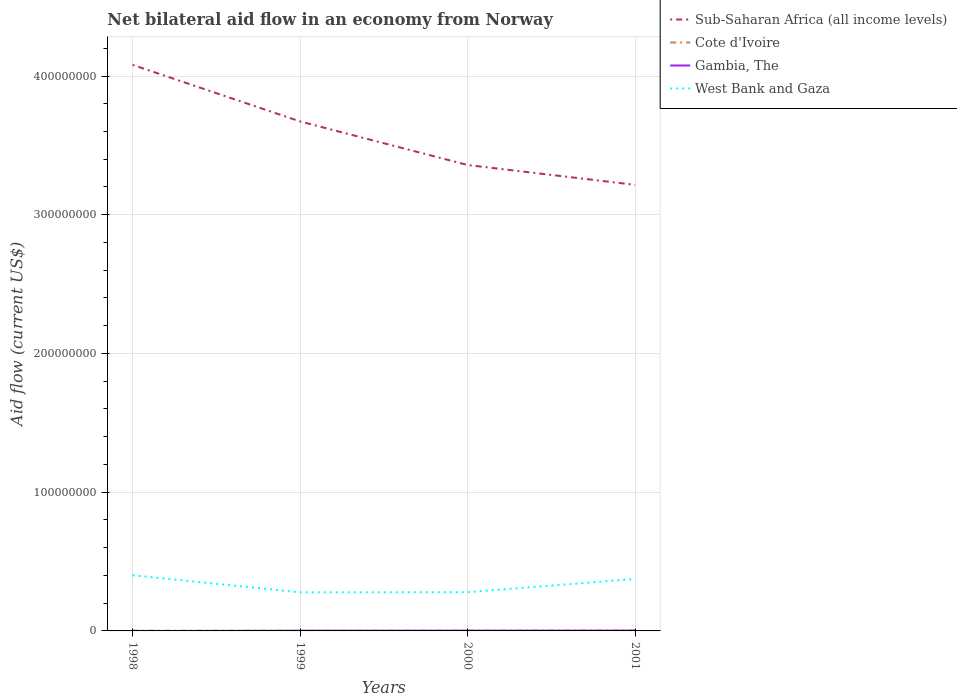Is the number of lines equal to the number of legend labels?
Make the answer very short. No. Across all years, what is the maximum net bilateral aid flow in Gambia, The?
Your answer should be very brief. 0. What is the total net bilateral aid flow in West Bank and Gaza in the graph?
Ensure brevity in your answer.  1.23e+07. What is the difference between the highest and the second highest net bilateral aid flow in Gambia, The?
Give a very brief answer. 2.40e+05. Is the net bilateral aid flow in Cote d'Ivoire strictly greater than the net bilateral aid flow in Sub-Saharan Africa (all income levels) over the years?
Offer a very short reply. Yes. How many lines are there?
Keep it short and to the point. 4. How many years are there in the graph?
Keep it short and to the point. 4. Are the values on the major ticks of Y-axis written in scientific E-notation?
Give a very brief answer. No. Does the graph contain any zero values?
Your answer should be very brief. Yes. Does the graph contain grids?
Ensure brevity in your answer.  Yes. Where does the legend appear in the graph?
Offer a terse response. Top right. What is the title of the graph?
Ensure brevity in your answer.  Net bilateral aid flow in an economy from Norway. What is the label or title of the X-axis?
Provide a short and direct response. Years. What is the Aid flow (current US$) of Sub-Saharan Africa (all income levels) in 1998?
Give a very brief answer. 4.08e+08. What is the Aid flow (current US$) in Cote d'Ivoire in 1998?
Your answer should be compact. 2.00e+05. What is the Aid flow (current US$) in West Bank and Gaza in 1998?
Your answer should be very brief. 4.01e+07. What is the Aid flow (current US$) of Sub-Saharan Africa (all income levels) in 1999?
Offer a terse response. 3.67e+08. What is the Aid flow (current US$) in Gambia, The in 1999?
Provide a short and direct response. 1.50e+05. What is the Aid flow (current US$) in West Bank and Gaza in 1999?
Offer a terse response. 2.78e+07. What is the Aid flow (current US$) of Sub-Saharan Africa (all income levels) in 2000?
Keep it short and to the point. 3.36e+08. What is the Aid flow (current US$) in Gambia, The in 2000?
Your response must be concise. 1.90e+05. What is the Aid flow (current US$) in West Bank and Gaza in 2000?
Your answer should be compact. 2.79e+07. What is the Aid flow (current US$) of Sub-Saharan Africa (all income levels) in 2001?
Your answer should be very brief. 3.22e+08. What is the Aid flow (current US$) in Cote d'Ivoire in 2001?
Make the answer very short. 2.40e+05. What is the Aid flow (current US$) in West Bank and Gaza in 2001?
Keep it short and to the point. 3.75e+07. Across all years, what is the maximum Aid flow (current US$) of Sub-Saharan Africa (all income levels)?
Your response must be concise. 4.08e+08. Across all years, what is the maximum Aid flow (current US$) of Gambia, The?
Offer a very short reply. 2.40e+05. Across all years, what is the maximum Aid flow (current US$) in West Bank and Gaza?
Keep it short and to the point. 4.01e+07. Across all years, what is the minimum Aid flow (current US$) in Sub-Saharan Africa (all income levels)?
Make the answer very short. 3.22e+08. Across all years, what is the minimum Aid flow (current US$) of West Bank and Gaza?
Offer a terse response. 2.78e+07. What is the total Aid flow (current US$) in Sub-Saharan Africa (all income levels) in the graph?
Ensure brevity in your answer.  1.43e+09. What is the total Aid flow (current US$) in Cote d'Ivoire in the graph?
Your answer should be compact. 6.80e+05. What is the total Aid flow (current US$) in Gambia, The in the graph?
Your answer should be very brief. 5.80e+05. What is the total Aid flow (current US$) in West Bank and Gaza in the graph?
Make the answer very short. 1.33e+08. What is the difference between the Aid flow (current US$) in Sub-Saharan Africa (all income levels) in 1998 and that in 1999?
Ensure brevity in your answer.  4.08e+07. What is the difference between the Aid flow (current US$) of West Bank and Gaza in 1998 and that in 1999?
Offer a terse response. 1.23e+07. What is the difference between the Aid flow (current US$) of Sub-Saharan Africa (all income levels) in 1998 and that in 2000?
Ensure brevity in your answer.  7.22e+07. What is the difference between the Aid flow (current US$) in Cote d'Ivoire in 1998 and that in 2000?
Your answer should be compact. 5.00e+04. What is the difference between the Aid flow (current US$) of West Bank and Gaza in 1998 and that in 2000?
Your response must be concise. 1.22e+07. What is the difference between the Aid flow (current US$) of Sub-Saharan Africa (all income levels) in 1998 and that in 2001?
Keep it short and to the point. 8.64e+07. What is the difference between the Aid flow (current US$) in West Bank and Gaza in 1998 and that in 2001?
Offer a terse response. 2.67e+06. What is the difference between the Aid flow (current US$) of Sub-Saharan Africa (all income levels) in 1999 and that in 2000?
Give a very brief answer. 3.14e+07. What is the difference between the Aid flow (current US$) in Cote d'Ivoire in 1999 and that in 2000?
Offer a terse response. -6.00e+04. What is the difference between the Aid flow (current US$) of Gambia, The in 1999 and that in 2000?
Provide a short and direct response. -4.00e+04. What is the difference between the Aid flow (current US$) of Sub-Saharan Africa (all income levels) in 1999 and that in 2001?
Provide a succinct answer. 4.57e+07. What is the difference between the Aid flow (current US$) in Cote d'Ivoire in 1999 and that in 2001?
Offer a terse response. -1.50e+05. What is the difference between the Aid flow (current US$) of Gambia, The in 1999 and that in 2001?
Offer a terse response. -9.00e+04. What is the difference between the Aid flow (current US$) in West Bank and Gaza in 1999 and that in 2001?
Offer a very short reply. -9.65e+06. What is the difference between the Aid flow (current US$) in Sub-Saharan Africa (all income levels) in 2000 and that in 2001?
Provide a succinct answer. 1.43e+07. What is the difference between the Aid flow (current US$) in Gambia, The in 2000 and that in 2001?
Offer a terse response. -5.00e+04. What is the difference between the Aid flow (current US$) in West Bank and Gaza in 2000 and that in 2001?
Give a very brief answer. -9.53e+06. What is the difference between the Aid flow (current US$) in Sub-Saharan Africa (all income levels) in 1998 and the Aid flow (current US$) in Cote d'Ivoire in 1999?
Your answer should be compact. 4.08e+08. What is the difference between the Aid flow (current US$) in Sub-Saharan Africa (all income levels) in 1998 and the Aid flow (current US$) in Gambia, The in 1999?
Keep it short and to the point. 4.08e+08. What is the difference between the Aid flow (current US$) in Sub-Saharan Africa (all income levels) in 1998 and the Aid flow (current US$) in West Bank and Gaza in 1999?
Ensure brevity in your answer.  3.80e+08. What is the difference between the Aid flow (current US$) in Cote d'Ivoire in 1998 and the Aid flow (current US$) in West Bank and Gaza in 1999?
Your response must be concise. -2.76e+07. What is the difference between the Aid flow (current US$) in Sub-Saharan Africa (all income levels) in 1998 and the Aid flow (current US$) in Cote d'Ivoire in 2000?
Your answer should be very brief. 4.08e+08. What is the difference between the Aid flow (current US$) in Sub-Saharan Africa (all income levels) in 1998 and the Aid flow (current US$) in Gambia, The in 2000?
Your answer should be compact. 4.08e+08. What is the difference between the Aid flow (current US$) of Sub-Saharan Africa (all income levels) in 1998 and the Aid flow (current US$) of West Bank and Gaza in 2000?
Offer a very short reply. 3.80e+08. What is the difference between the Aid flow (current US$) in Cote d'Ivoire in 1998 and the Aid flow (current US$) in West Bank and Gaza in 2000?
Offer a very short reply. -2.77e+07. What is the difference between the Aid flow (current US$) in Sub-Saharan Africa (all income levels) in 1998 and the Aid flow (current US$) in Cote d'Ivoire in 2001?
Offer a terse response. 4.08e+08. What is the difference between the Aid flow (current US$) of Sub-Saharan Africa (all income levels) in 1998 and the Aid flow (current US$) of Gambia, The in 2001?
Give a very brief answer. 4.08e+08. What is the difference between the Aid flow (current US$) of Sub-Saharan Africa (all income levels) in 1998 and the Aid flow (current US$) of West Bank and Gaza in 2001?
Ensure brevity in your answer.  3.71e+08. What is the difference between the Aid flow (current US$) of Cote d'Ivoire in 1998 and the Aid flow (current US$) of West Bank and Gaza in 2001?
Provide a succinct answer. -3.73e+07. What is the difference between the Aid flow (current US$) of Sub-Saharan Africa (all income levels) in 1999 and the Aid flow (current US$) of Cote d'Ivoire in 2000?
Keep it short and to the point. 3.67e+08. What is the difference between the Aid flow (current US$) of Sub-Saharan Africa (all income levels) in 1999 and the Aid flow (current US$) of Gambia, The in 2000?
Offer a very short reply. 3.67e+08. What is the difference between the Aid flow (current US$) in Sub-Saharan Africa (all income levels) in 1999 and the Aid flow (current US$) in West Bank and Gaza in 2000?
Give a very brief answer. 3.39e+08. What is the difference between the Aid flow (current US$) of Cote d'Ivoire in 1999 and the Aid flow (current US$) of West Bank and Gaza in 2000?
Provide a succinct answer. -2.78e+07. What is the difference between the Aid flow (current US$) of Gambia, The in 1999 and the Aid flow (current US$) of West Bank and Gaza in 2000?
Give a very brief answer. -2.78e+07. What is the difference between the Aid flow (current US$) in Sub-Saharan Africa (all income levels) in 1999 and the Aid flow (current US$) in Cote d'Ivoire in 2001?
Provide a succinct answer. 3.67e+08. What is the difference between the Aid flow (current US$) in Sub-Saharan Africa (all income levels) in 1999 and the Aid flow (current US$) in Gambia, The in 2001?
Make the answer very short. 3.67e+08. What is the difference between the Aid flow (current US$) in Sub-Saharan Africa (all income levels) in 1999 and the Aid flow (current US$) in West Bank and Gaza in 2001?
Provide a short and direct response. 3.30e+08. What is the difference between the Aid flow (current US$) in Cote d'Ivoire in 1999 and the Aid flow (current US$) in West Bank and Gaza in 2001?
Your answer should be compact. -3.74e+07. What is the difference between the Aid flow (current US$) of Gambia, The in 1999 and the Aid flow (current US$) of West Bank and Gaza in 2001?
Your answer should be compact. -3.73e+07. What is the difference between the Aid flow (current US$) in Sub-Saharan Africa (all income levels) in 2000 and the Aid flow (current US$) in Cote d'Ivoire in 2001?
Ensure brevity in your answer.  3.36e+08. What is the difference between the Aid flow (current US$) in Sub-Saharan Africa (all income levels) in 2000 and the Aid flow (current US$) in Gambia, The in 2001?
Your answer should be compact. 3.36e+08. What is the difference between the Aid flow (current US$) in Sub-Saharan Africa (all income levels) in 2000 and the Aid flow (current US$) in West Bank and Gaza in 2001?
Offer a terse response. 2.98e+08. What is the difference between the Aid flow (current US$) in Cote d'Ivoire in 2000 and the Aid flow (current US$) in Gambia, The in 2001?
Offer a very short reply. -9.00e+04. What is the difference between the Aid flow (current US$) in Cote d'Ivoire in 2000 and the Aid flow (current US$) in West Bank and Gaza in 2001?
Your response must be concise. -3.73e+07. What is the difference between the Aid flow (current US$) of Gambia, The in 2000 and the Aid flow (current US$) of West Bank and Gaza in 2001?
Provide a short and direct response. -3.73e+07. What is the average Aid flow (current US$) in Sub-Saharan Africa (all income levels) per year?
Make the answer very short. 3.58e+08. What is the average Aid flow (current US$) of Gambia, The per year?
Keep it short and to the point. 1.45e+05. What is the average Aid flow (current US$) in West Bank and Gaza per year?
Offer a terse response. 3.33e+07. In the year 1998, what is the difference between the Aid flow (current US$) of Sub-Saharan Africa (all income levels) and Aid flow (current US$) of Cote d'Ivoire?
Make the answer very short. 4.08e+08. In the year 1998, what is the difference between the Aid flow (current US$) in Sub-Saharan Africa (all income levels) and Aid flow (current US$) in West Bank and Gaza?
Offer a terse response. 3.68e+08. In the year 1998, what is the difference between the Aid flow (current US$) of Cote d'Ivoire and Aid flow (current US$) of West Bank and Gaza?
Your answer should be very brief. -3.99e+07. In the year 1999, what is the difference between the Aid flow (current US$) of Sub-Saharan Africa (all income levels) and Aid flow (current US$) of Cote d'Ivoire?
Your response must be concise. 3.67e+08. In the year 1999, what is the difference between the Aid flow (current US$) of Sub-Saharan Africa (all income levels) and Aid flow (current US$) of Gambia, The?
Ensure brevity in your answer.  3.67e+08. In the year 1999, what is the difference between the Aid flow (current US$) in Sub-Saharan Africa (all income levels) and Aid flow (current US$) in West Bank and Gaza?
Your answer should be compact. 3.39e+08. In the year 1999, what is the difference between the Aid flow (current US$) of Cote d'Ivoire and Aid flow (current US$) of West Bank and Gaza?
Offer a terse response. -2.77e+07. In the year 1999, what is the difference between the Aid flow (current US$) of Gambia, The and Aid flow (current US$) of West Bank and Gaza?
Provide a succinct answer. -2.77e+07. In the year 2000, what is the difference between the Aid flow (current US$) of Sub-Saharan Africa (all income levels) and Aid flow (current US$) of Cote d'Ivoire?
Offer a very short reply. 3.36e+08. In the year 2000, what is the difference between the Aid flow (current US$) of Sub-Saharan Africa (all income levels) and Aid flow (current US$) of Gambia, The?
Provide a succinct answer. 3.36e+08. In the year 2000, what is the difference between the Aid flow (current US$) of Sub-Saharan Africa (all income levels) and Aid flow (current US$) of West Bank and Gaza?
Offer a very short reply. 3.08e+08. In the year 2000, what is the difference between the Aid flow (current US$) in Cote d'Ivoire and Aid flow (current US$) in Gambia, The?
Your answer should be compact. -4.00e+04. In the year 2000, what is the difference between the Aid flow (current US$) of Cote d'Ivoire and Aid flow (current US$) of West Bank and Gaza?
Ensure brevity in your answer.  -2.78e+07. In the year 2000, what is the difference between the Aid flow (current US$) of Gambia, The and Aid flow (current US$) of West Bank and Gaza?
Provide a short and direct response. -2.77e+07. In the year 2001, what is the difference between the Aid flow (current US$) of Sub-Saharan Africa (all income levels) and Aid flow (current US$) of Cote d'Ivoire?
Your answer should be compact. 3.21e+08. In the year 2001, what is the difference between the Aid flow (current US$) of Sub-Saharan Africa (all income levels) and Aid flow (current US$) of Gambia, The?
Your answer should be compact. 3.21e+08. In the year 2001, what is the difference between the Aid flow (current US$) of Sub-Saharan Africa (all income levels) and Aid flow (current US$) of West Bank and Gaza?
Provide a succinct answer. 2.84e+08. In the year 2001, what is the difference between the Aid flow (current US$) of Cote d'Ivoire and Aid flow (current US$) of Gambia, The?
Keep it short and to the point. 0. In the year 2001, what is the difference between the Aid flow (current US$) of Cote d'Ivoire and Aid flow (current US$) of West Bank and Gaza?
Offer a terse response. -3.72e+07. In the year 2001, what is the difference between the Aid flow (current US$) of Gambia, The and Aid flow (current US$) of West Bank and Gaza?
Offer a very short reply. -3.72e+07. What is the ratio of the Aid flow (current US$) in Sub-Saharan Africa (all income levels) in 1998 to that in 1999?
Offer a terse response. 1.11. What is the ratio of the Aid flow (current US$) of Cote d'Ivoire in 1998 to that in 1999?
Keep it short and to the point. 2.22. What is the ratio of the Aid flow (current US$) of West Bank and Gaza in 1998 to that in 1999?
Provide a short and direct response. 1.44. What is the ratio of the Aid flow (current US$) of Sub-Saharan Africa (all income levels) in 1998 to that in 2000?
Give a very brief answer. 1.21. What is the ratio of the Aid flow (current US$) of Cote d'Ivoire in 1998 to that in 2000?
Ensure brevity in your answer.  1.33. What is the ratio of the Aid flow (current US$) in West Bank and Gaza in 1998 to that in 2000?
Your answer should be compact. 1.44. What is the ratio of the Aid flow (current US$) in Sub-Saharan Africa (all income levels) in 1998 to that in 2001?
Keep it short and to the point. 1.27. What is the ratio of the Aid flow (current US$) in West Bank and Gaza in 1998 to that in 2001?
Offer a very short reply. 1.07. What is the ratio of the Aid flow (current US$) in Sub-Saharan Africa (all income levels) in 1999 to that in 2000?
Keep it short and to the point. 1.09. What is the ratio of the Aid flow (current US$) in Gambia, The in 1999 to that in 2000?
Give a very brief answer. 0.79. What is the ratio of the Aid flow (current US$) of West Bank and Gaza in 1999 to that in 2000?
Make the answer very short. 1. What is the ratio of the Aid flow (current US$) of Sub-Saharan Africa (all income levels) in 1999 to that in 2001?
Offer a terse response. 1.14. What is the ratio of the Aid flow (current US$) in West Bank and Gaza in 1999 to that in 2001?
Your answer should be very brief. 0.74. What is the ratio of the Aid flow (current US$) in Sub-Saharan Africa (all income levels) in 2000 to that in 2001?
Make the answer very short. 1.04. What is the ratio of the Aid flow (current US$) in Cote d'Ivoire in 2000 to that in 2001?
Give a very brief answer. 0.62. What is the ratio of the Aid flow (current US$) of Gambia, The in 2000 to that in 2001?
Provide a succinct answer. 0.79. What is the ratio of the Aid flow (current US$) of West Bank and Gaza in 2000 to that in 2001?
Provide a succinct answer. 0.75. What is the difference between the highest and the second highest Aid flow (current US$) in Sub-Saharan Africa (all income levels)?
Ensure brevity in your answer.  4.08e+07. What is the difference between the highest and the second highest Aid flow (current US$) of Gambia, The?
Ensure brevity in your answer.  5.00e+04. What is the difference between the highest and the second highest Aid flow (current US$) in West Bank and Gaza?
Provide a short and direct response. 2.67e+06. What is the difference between the highest and the lowest Aid flow (current US$) of Sub-Saharan Africa (all income levels)?
Provide a succinct answer. 8.64e+07. What is the difference between the highest and the lowest Aid flow (current US$) in Gambia, The?
Your answer should be compact. 2.40e+05. What is the difference between the highest and the lowest Aid flow (current US$) in West Bank and Gaza?
Offer a terse response. 1.23e+07. 